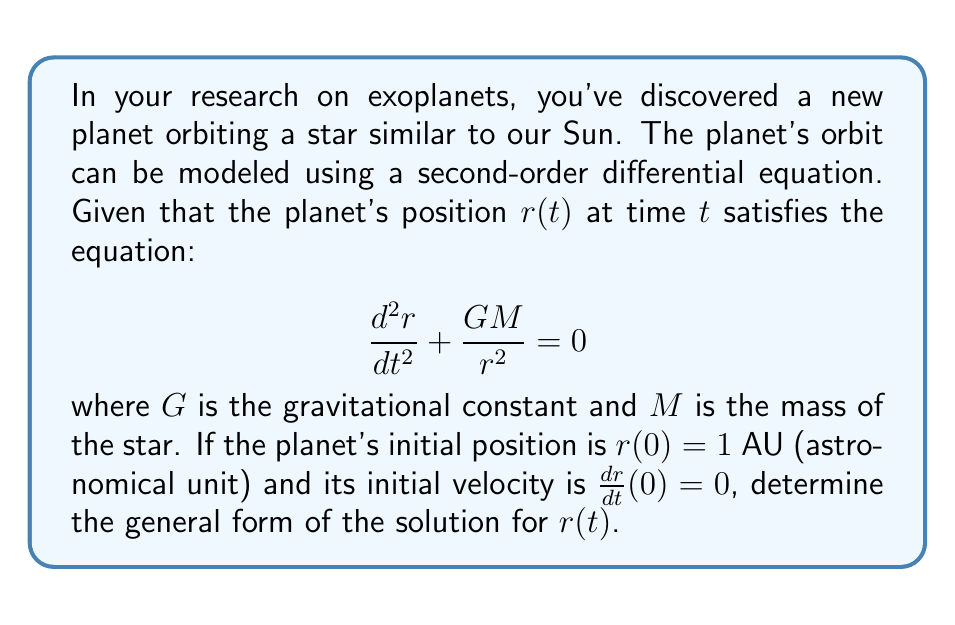Help me with this question. To solve this problem, we'll follow these steps:

1) First, we recognize that this is a nonlinear second-order differential equation. It's not immediately solvable in its current form.

2) To simplify, we can introduce a new variable $u = \frac{1}{r}$. This substitution is known as the Binet transformation.

3) Using the chain rule, we can express $\frac{dr}{dt}$ and $\frac{d^2r}{dt^2}$ in terms of $u$:

   $\frac{dr}{dt} = -\frac{1}{u^2}\frac{du}{dt}$
   
   $\frac{d^2r}{dt^2} = -\frac{d}{dt}(\frac{1}{u^2}\frac{du}{dt}) = \frac{2}{u^3}(\frac{du}{dt})^2 - \frac{1}{u^2}\frac{d^2u}{dt^2}$

4) Substituting these into our original equation:

   $\frac{2}{u^3}(\frac{du}{dt})^2 - \frac{1}{u^2}\frac{d^2u}{dt^2} + GMu^2 = 0$

5) Multiply throughout by $u^2$:

   $2u(\frac{du}{dt})^2 - \frac{d^2u}{dt^2} + GMu^4 = 0$

6) Now, let's introduce a new independent variable $\theta$ such that $\frac{d\theta}{dt} = h$, where $h$ is a constant (this represents the angular momentum per unit mass).

7) Using the chain rule:

   $\frac{du}{dt} = \frac{du}{d\theta}\frac{d\theta}{dt} = h\frac{du}{d\theta}$
   
   $\frac{d^2u}{dt^2} = h^2\frac{d^2u}{d\theta^2}$

8) Substituting these into our equation:

   $2uh^2(\frac{du}{d\theta})^2 - h^2\frac{d^2u}{d\theta^2} + GMu^4 = 0$

9) Dividing by $h^2$ throughout:

   $2u(\frac{du}{d\theta})^2 - \frac{d^2u}{d\theta^2} + \frac{GM}{h^2}u^4 = 0$

10) This equation has a solution of the form:

    $u = A + B\cos(\theta)$

    where $A$ and $B$ are constants.

11) Substituting back $r = \frac{1}{u}$, we get:

    $r = \frac{1}{A + B\cos(\theta)}$

This is the general form of the solution, representing a conic section. The specific type of orbit (circular, elliptical, parabolic, or hyperbolic) depends on the values of $A$ and $B$.
Answer: The general form of the solution for $r(t)$ is:

$$r(\theta) = \frac{1}{A + B\cos(\theta)}$$

where $A$ and $B$ are constants determined by the initial conditions, and $\theta$ is related to time $t$ by $\frac{d\theta}{dt} = h$, with $h$ being a constant representing angular momentum per unit mass. 